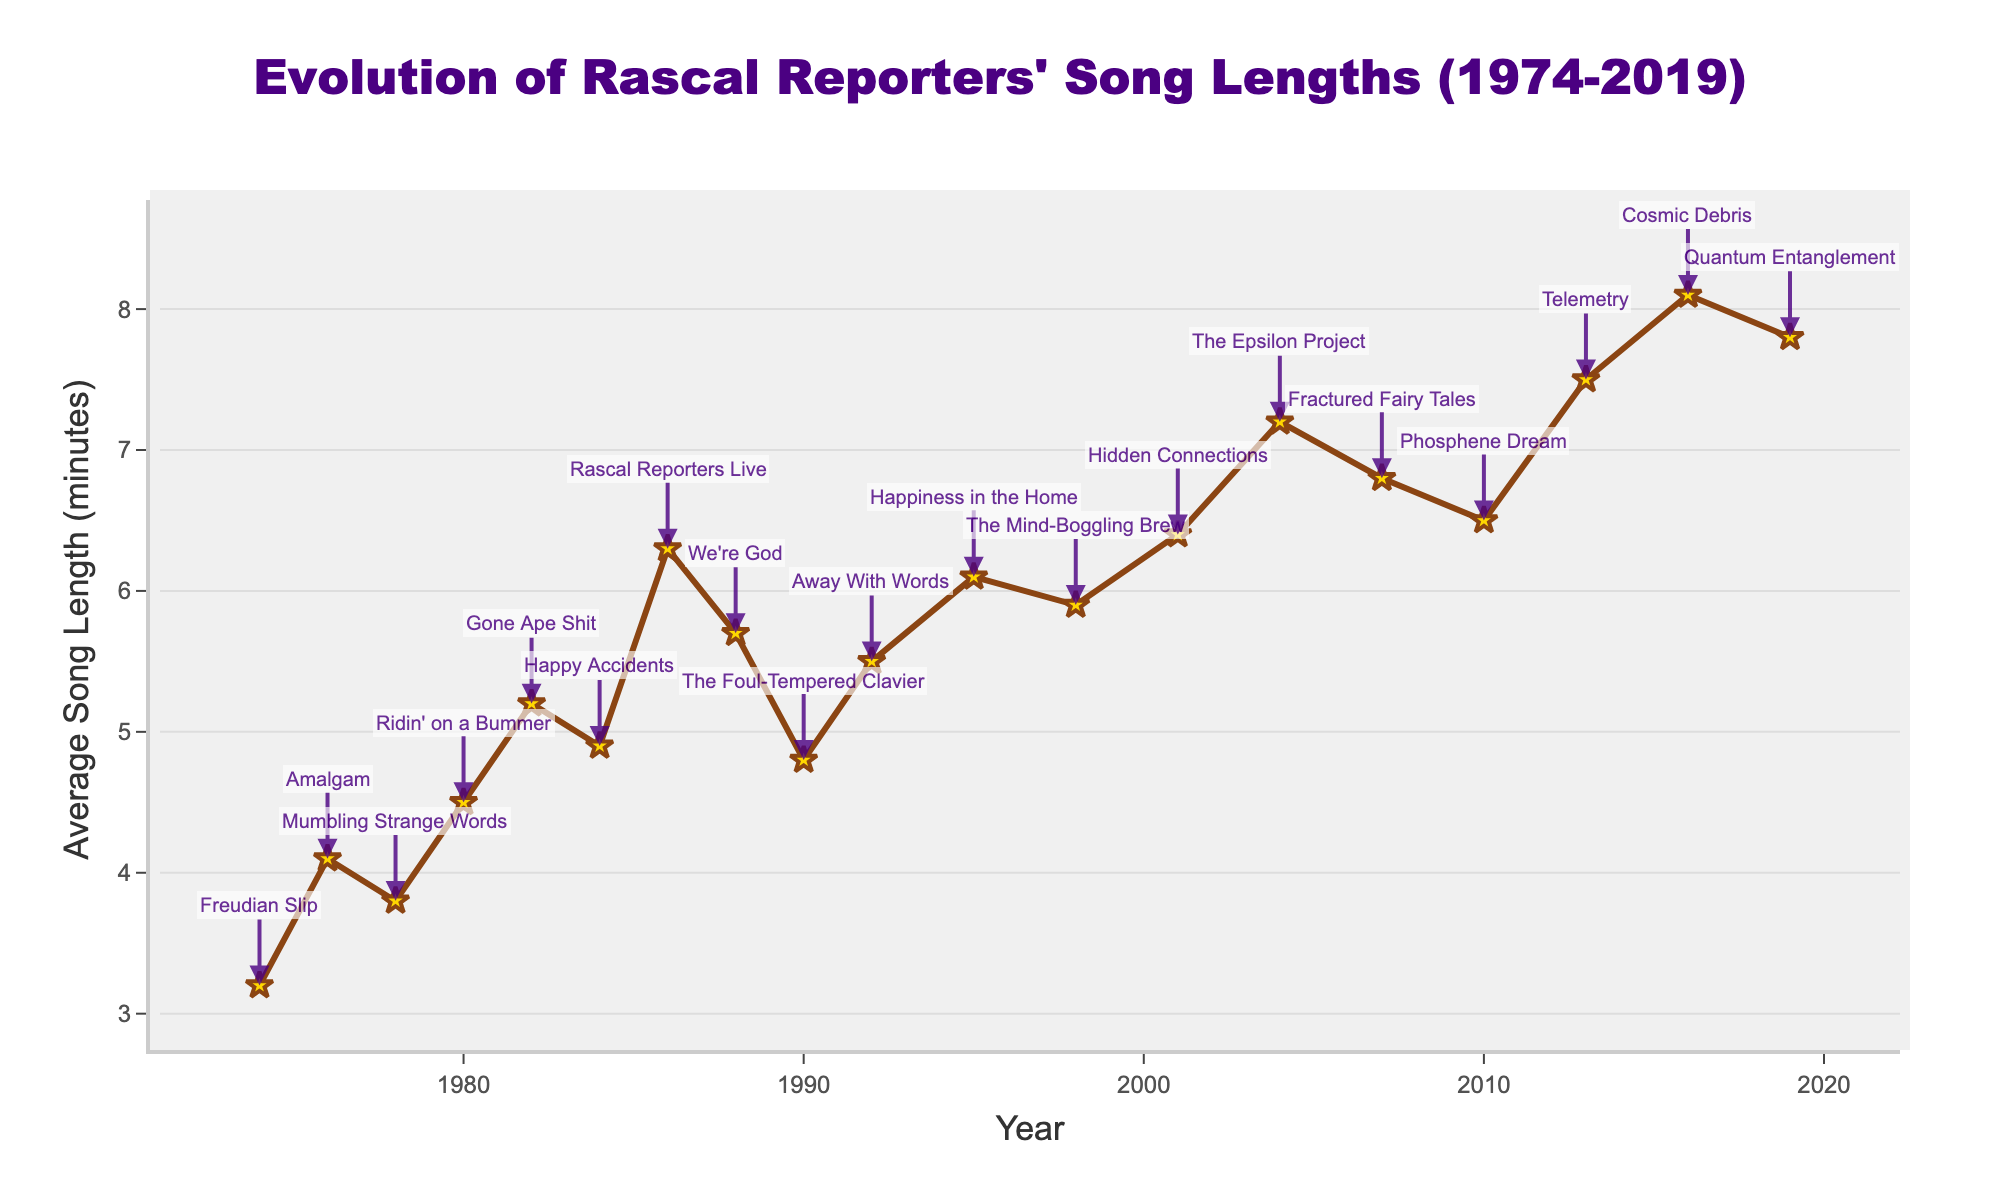What's the longest average song length in the Rascal Reporters' discography? The longest average song length corresponds to the peak of the line on the graph. The peak is at the album "Cosmic Debris" in 2016 with an average song length of 8.1 minutes.
Answer: 8.1 minutes Which album marked the first time Rascal Reporters' average song length exceeded 5 minutes? Identify the first album to exceed the 5-minute mark on the line graph. This point occurs at the album "Gone Ape Shit" in 1982, where the average song length is 5.2 minutes.
Answer: Gone Ape Shit Compare the average song length between "Freudian Slip" and "Telemetry". Which one is longer and by how much? Find the points for "Freudian Slip" (1974) and "Telemetry" (2013) on the graph. "Freudian Slip" has an average song length of 3.2 minutes, and "Telemetry" has 7.5 minutes. Subtract 3.2 from 7.5 to find the difference.
Answer: Telemetry by 4.3 minutes How many albums have an average song length greater than 6 minutes? Count the number of data points above the 6-minute mark on the chart. These albums are "Rascal Reporters Live", "Happiness in the Home", "Hidden Connections", "The Epsilon Project", "Fractured Fairy Tales", "Phosphene Dream", "Telemetry", "Cosmic Debris", and "Quantum Entanglement".
Answer: 9 What is the average song length of all albums released in the 1980s? Find the albums from the 1980s: "Ridin' on a Bummer" (1980, 4.5), "Gone Ape Shit" (1982, 5.2), "Happy Accidents" (1984, 4.9), "Rascal Reporters Live" (1986, 6.3), "We're God" (1988, 5.7). Sum these lengths: 4.5 + 5.2 + 4.9 + 6.3 + 5.7 = 26.6. Divide by the number of albums (5) to get the average.
Answer: 5.32 minutes Which album achieved a significant increase in average song length compared to its predecessor? Look for a steep upward slope between two consecutive points on the graph. The largest increase is between "Happy Accidents" (1984, 4.9 minutes) and "Rascal Reporters Live" (1986, 6.3 minutes). Subtract 4.9 from 6.3 to see the increase.
Answer: Rascal Reporters Live by 1.4 minutes 